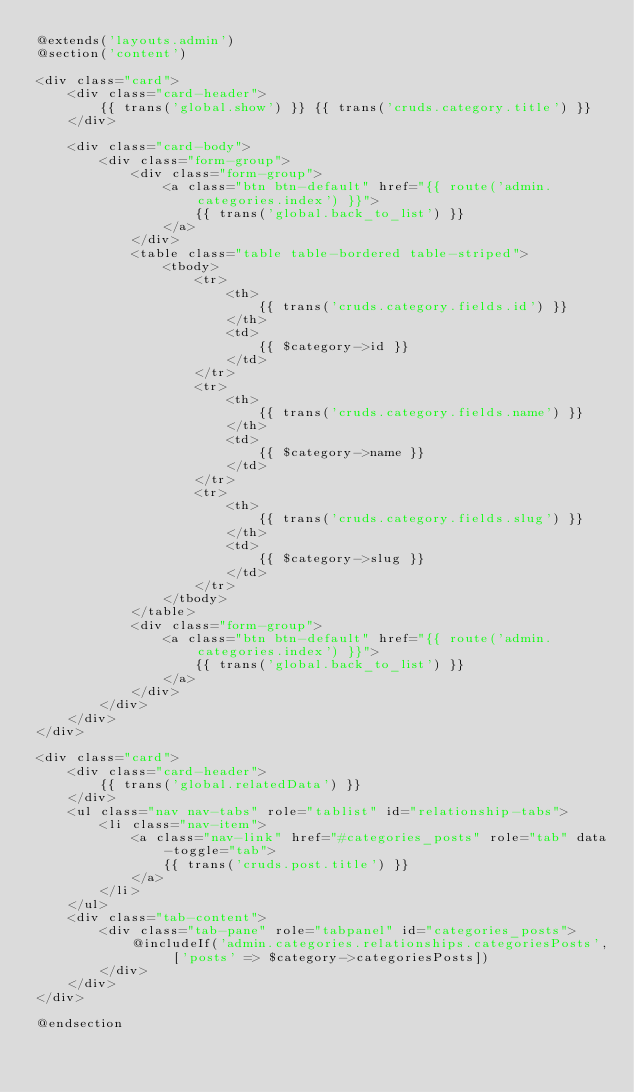<code> <loc_0><loc_0><loc_500><loc_500><_PHP_>@extends('layouts.admin')
@section('content')

<div class="card">
    <div class="card-header">
        {{ trans('global.show') }} {{ trans('cruds.category.title') }}
    </div>

    <div class="card-body">
        <div class="form-group">
            <div class="form-group">
                <a class="btn btn-default" href="{{ route('admin.categories.index') }}">
                    {{ trans('global.back_to_list') }}
                </a>
            </div>
            <table class="table table-bordered table-striped">
                <tbody>
                    <tr>
                        <th>
                            {{ trans('cruds.category.fields.id') }}
                        </th>
                        <td>
                            {{ $category->id }}
                        </td>
                    </tr>
                    <tr>
                        <th>
                            {{ trans('cruds.category.fields.name') }}
                        </th>
                        <td>
                            {{ $category->name }}
                        </td>
                    </tr>
                    <tr>
                        <th>
                            {{ trans('cruds.category.fields.slug') }}
                        </th>
                        <td>
                            {{ $category->slug }}
                        </td>
                    </tr>
                </tbody>
            </table>
            <div class="form-group">
                <a class="btn btn-default" href="{{ route('admin.categories.index') }}">
                    {{ trans('global.back_to_list') }}
                </a>
            </div>
        </div>
    </div>
</div>

<div class="card">
    <div class="card-header">
        {{ trans('global.relatedData') }}
    </div>
    <ul class="nav nav-tabs" role="tablist" id="relationship-tabs">
        <li class="nav-item">
            <a class="nav-link" href="#categories_posts" role="tab" data-toggle="tab">
                {{ trans('cruds.post.title') }}
            </a>
        </li>
    </ul>
    <div class="tab-content">
        <div class="tab-pane" role="tabpanel" id="categories_posts">
            @includeIf('admin.categories.relationships.categoriesPosts', ['posts' => $category->categoriesPosts])
        </div>
    </div>
</div>

@endsection</code> 